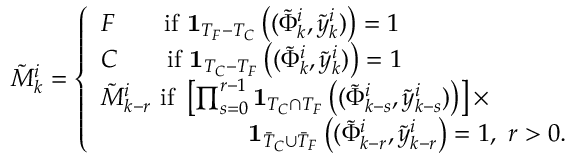<formula> <loc_0><loc_0><loc_500><loc_500>\tilde { M } _ { k } ^ { i } = \left \{ \begin{array} { l l } { F \quad i f \ 1 _ { T _ { F } - T _ { C } } \left ( ( \tilde { \Phi } _ { k } ^ { i } , \tilde { y } _ { k } ^ { i } ) \right ) = 1 } \\ { C \quad i f \ 1 _ { T _ { C } - T _ { F } } \left ( ( \tilde { \Phi } _ { k } ^ { i } , \tilde { y } _ { k } ^ { i } ) \right ) = 1 } \\ { \tilde { M } _ { k - r } ^ { i } \ i f \ \left [ \prod _ { s = 0 } ^ { r - 1 } 1 _ { T _ { C } \cap T _ { F } } \left ( ( \tilde { \Phi } _ { k - s } ^ { i } , \tilde { y } _ { k - s } ^ { i } ) \right ) \right ] \times } \\ { \quad 1 _ { \bar { T } _ { C } \cup \bar { T } _ { F } } \left ( ( \tilde { \Phi } _ { k - r } ^ { i } , \tilde { y } _ { k - r } ^ { i } \right ) = 1 , \ r > 0 . } \end{array}</formula> 